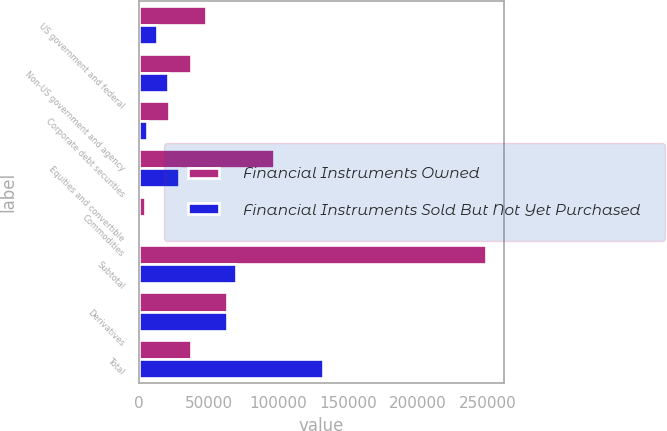Convert chart. <chart><loc_0><loc_0><loc_500><loc_500><stacked_bar_chart><ecel><fcel>US government and federal<fcel>Non-US government and agency<fcel>Corporate debt securities<fcel>Equities and convertible<fcel>Commodities<fcel>Subtotal<fcel>Derivatives<fcel>Total<nl><fcel>Financial Instruments Owned<fcel>48002<fcel>37059<fcel>21603<fcel>96442<fcel>3846<fcel>248978<fcel>63270<fcel>37059<nl><fcel>Financial Instruments Sold But Not Yet Purchased<fcel>12762<fcel>20500<fcel>5800<fcel>28314<fcel>1224<fcel>69067<fcel>63016<fcel>132083<nl></chart> 